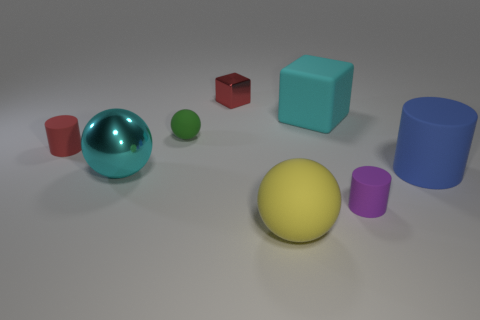Add 2 big blue cylinders. How many objects exist? 10 Subtract all balls. How many objects are left? 5 Subtract all red metal cubes. Subtract all large cylinders. How many objects are left? 6 Add 8 big yellow things. How many big yellow things are left? 9 Add 6 large purple balls. How many large purple balls exist? 6 Subtract 0 blue blocks. How many objects are left? 8 